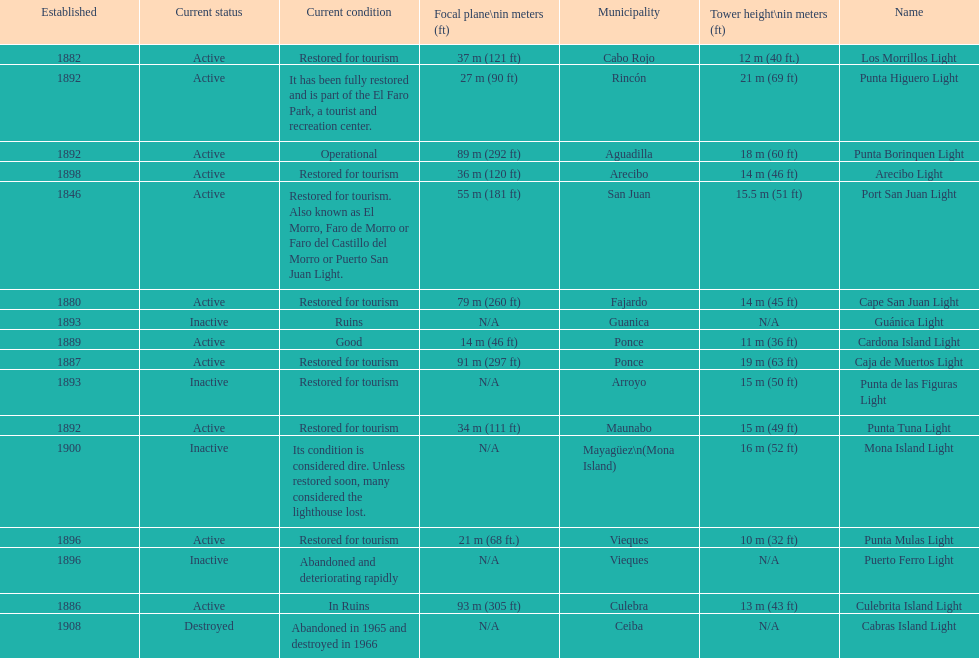How many towers are at least 18 meters tall? 3. 